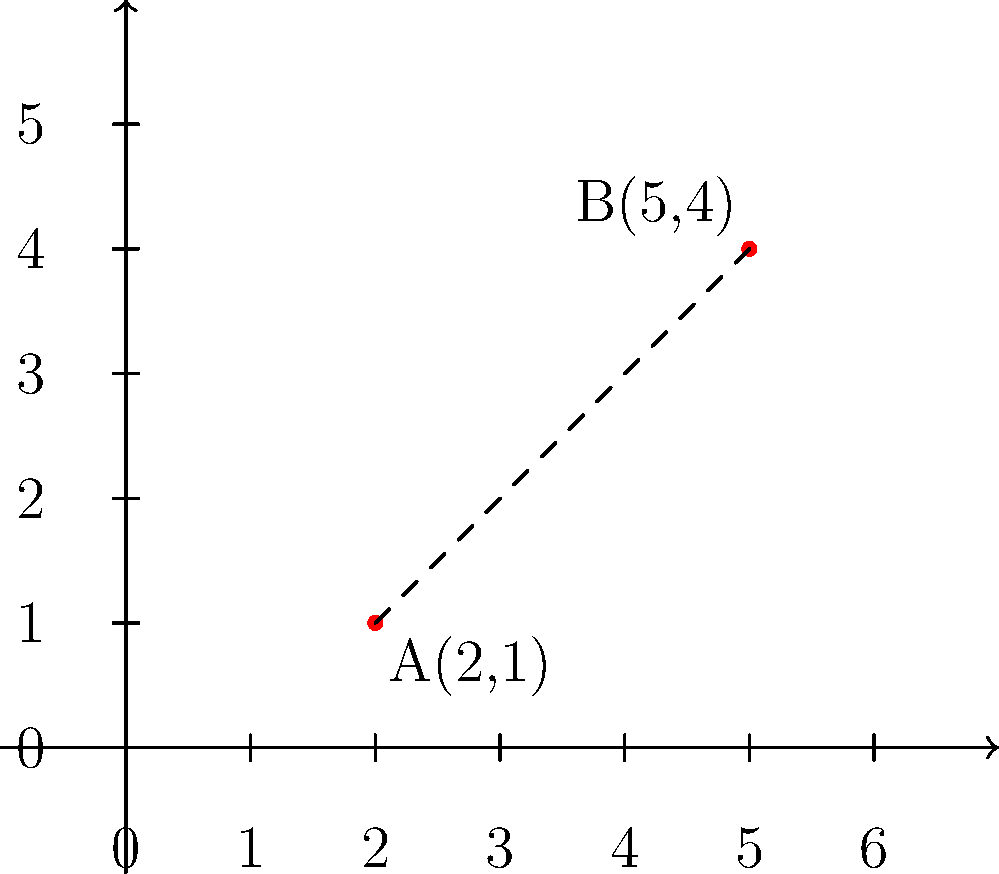Given two points A(2,1) and B(5,4) on a 2D coordinate plane, calculate the distance between them using the distance formula. Round your answer to two decimal places. To find the distance between two points in a 2D coordinate plane, we can use the distance formula:

$$d = \sqrt{(x_2 - x_1)^2 + (y_2 - y_1)^2}$$

Where $(x_1, y_1)$ are the coordinates of the first point and $(x_2, y_2)$ are the coordinates of the second point.

Let's break it down step by step:

1. Identify the coordinates:
   Point A: $(x_1, y_1) = (2, 1)$
   Point B: $(x_2, y_2) = (5, 4)$

2. Calculate the differences:
   $x_2 - x_1 = 5 - 2 = 3$
   $y_2 - y_1 = 4 - 1 = 3$

3. Square the differences:
   $(x_2 - x_1)^2 = 3^2 = 9$
   $(y_2 - y_1)^2 = 3^2 = 9$

4. Sum the squared differences:
   $(x_2 - x_1)^2 + (y_2 - y_1)^2 = 9 + 9 = 18$

5. Take the square root:
   $d = \sqrt{18}$

6. Simplify:
   $d = 3\sqrt{2} \approx 4.24$

7. Round to two decimal places:
   $d \approx 4.24$

Therefore, the distance between points A and B is approximately 4.24 units.
Answer: 4.24 units 